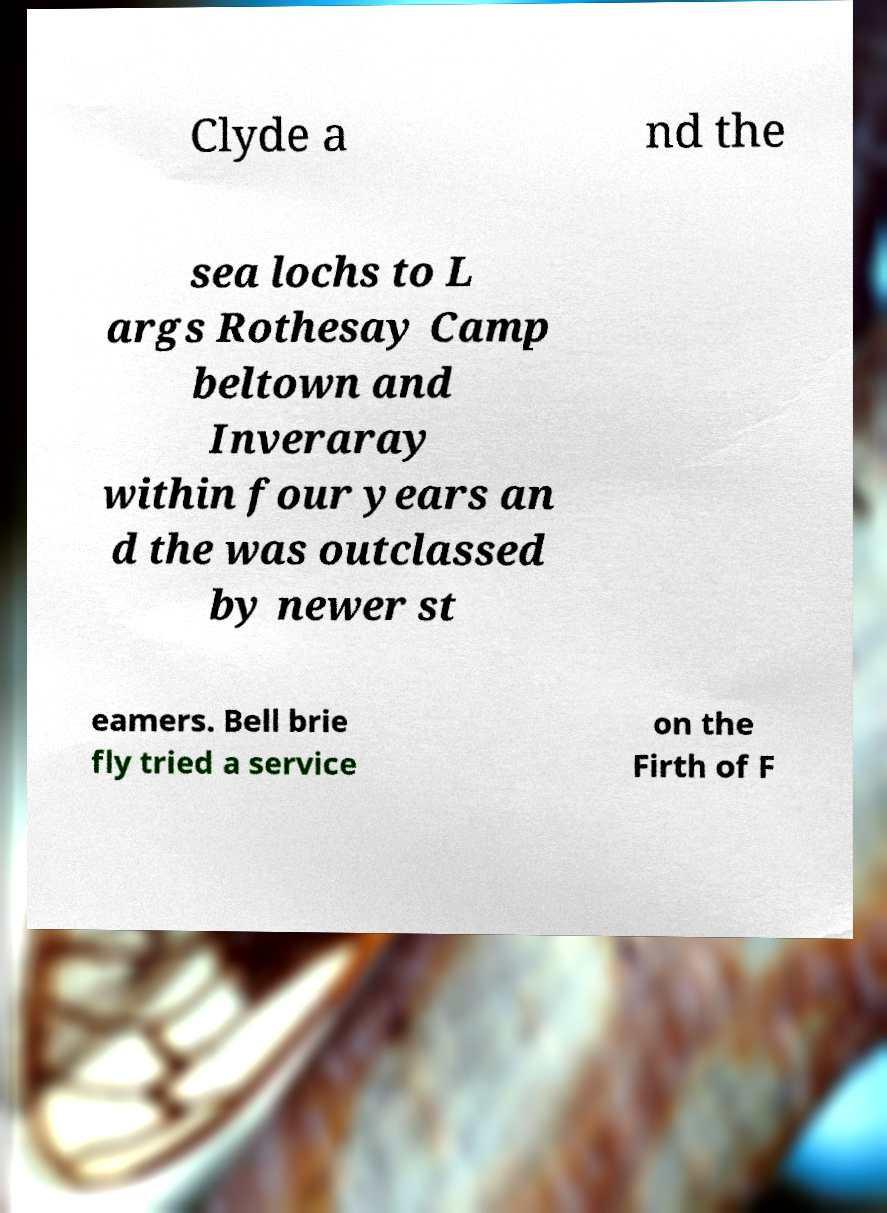Can you read and provide the text displayed in the image?This photo seems to have some interesting text. Can you extract and type it out for me? Clyde a nd the sea lochs to L args Rothesay Camp beltown and Inveraray within four years an d the was outclassed by newer st eamers. Bell brie fly tried a service on the Firth of F 